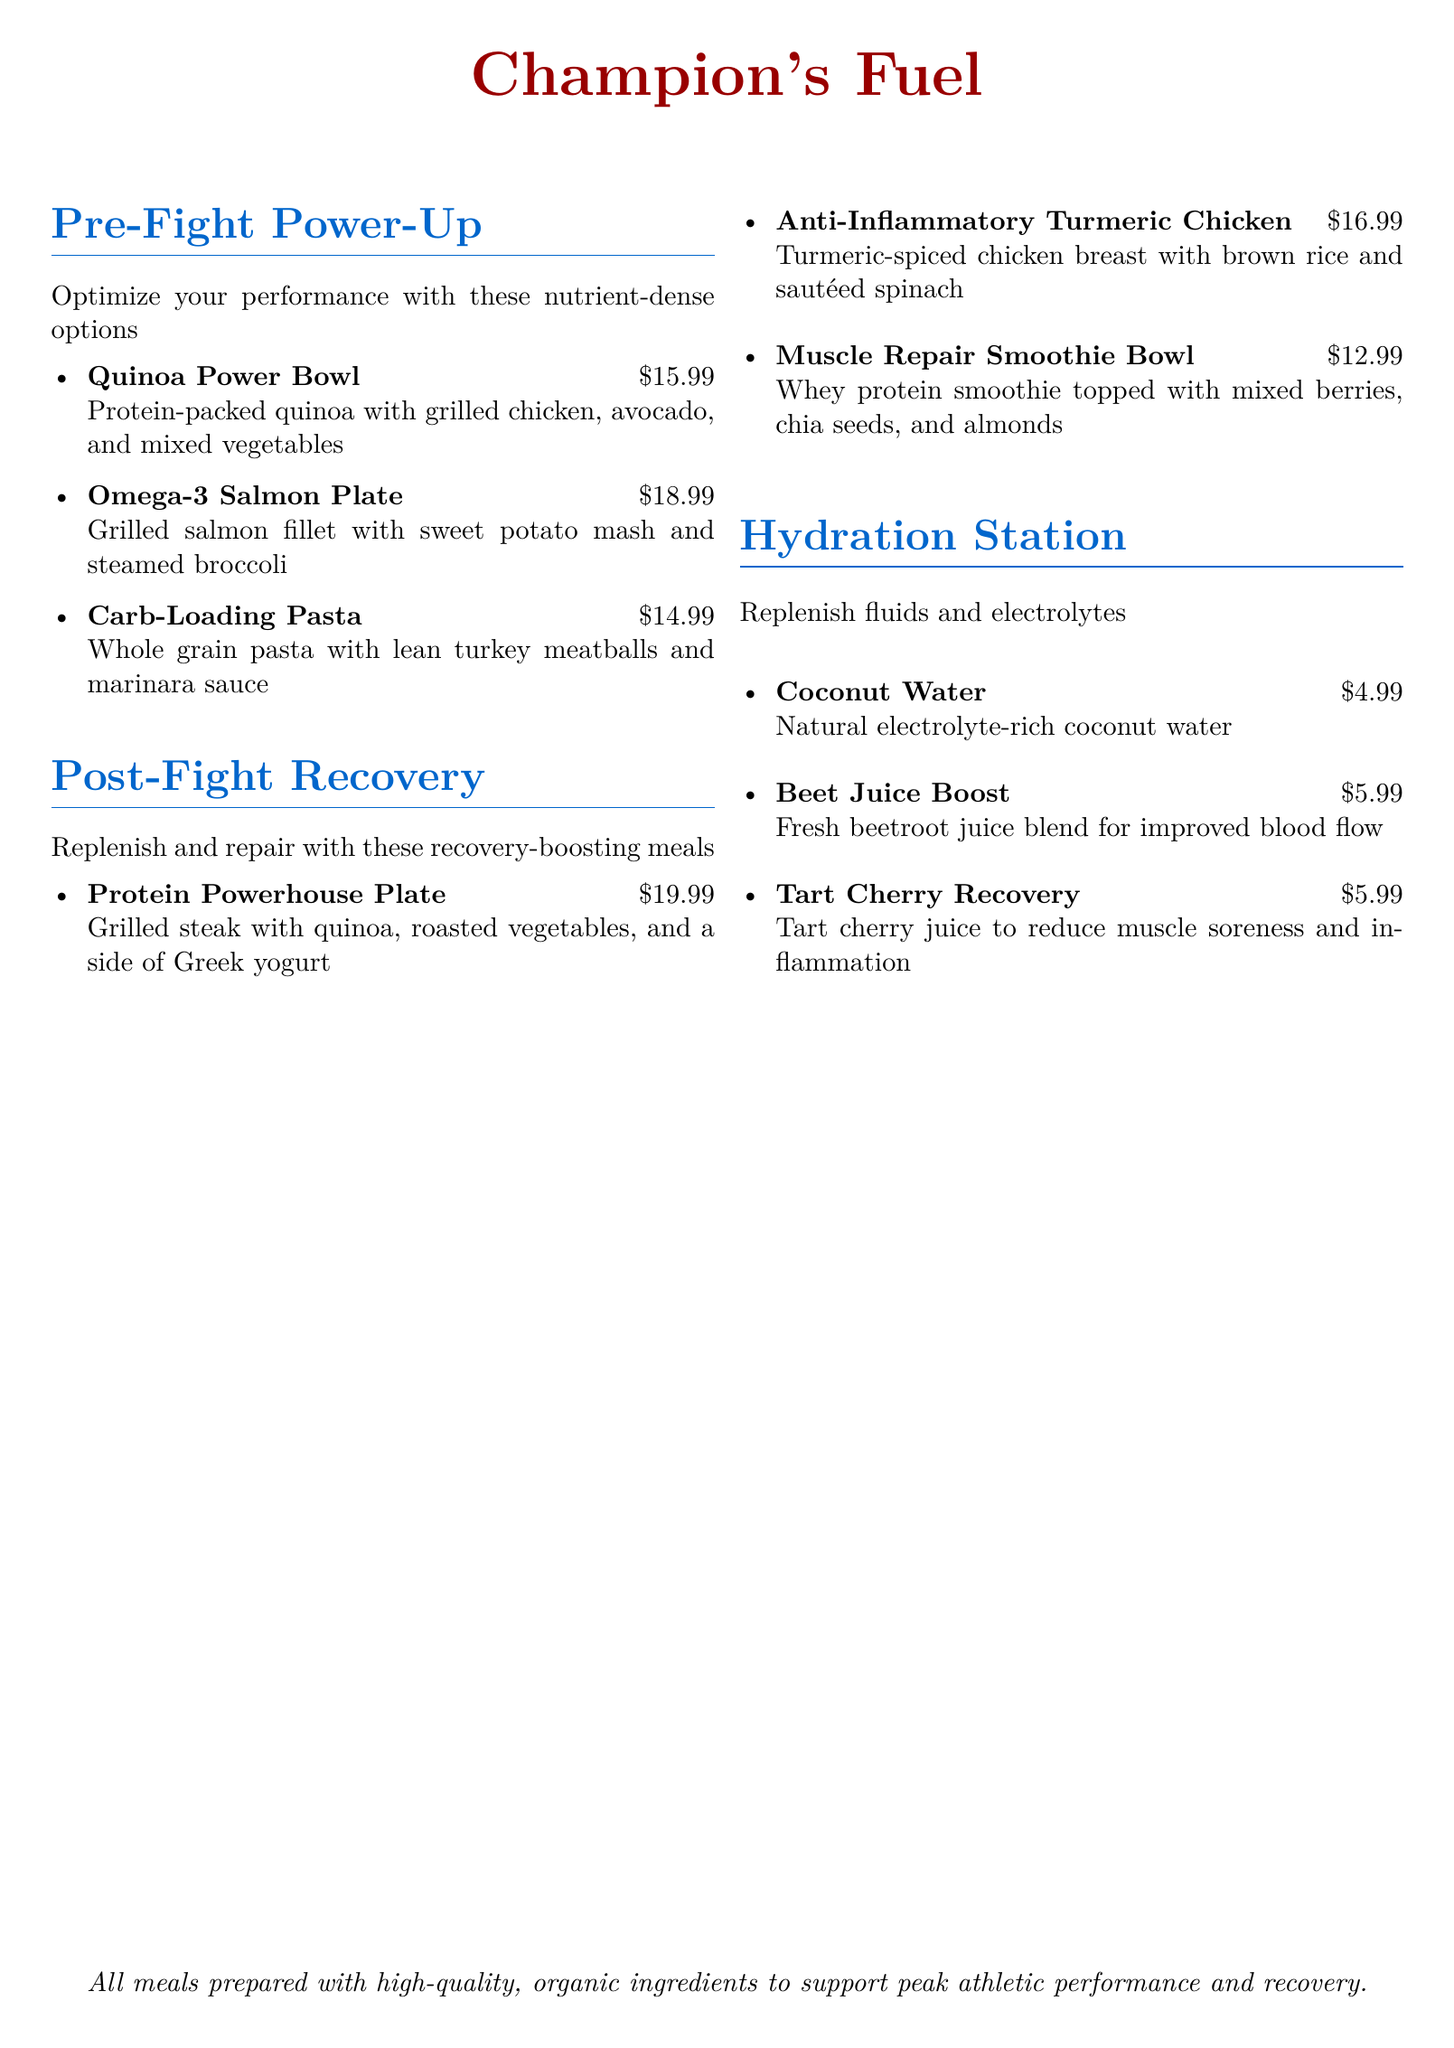What is the name of the restaurant? The name of the restaurant is clearly stated at the top of the document.
Answer: Champion's Fuel What is the price of the Omega-3 Salmon Plate? The price of each dish is listed next to the name. The Omega-3 Salmon Plate is priced at $18.99.
Answer: $18.99 How many items are included in the Pre-Fight menu? The number of items can be determined by counting the bullet points under the Pre-Fight section. There are three items.
Answer: 3 What is a key ingredient in the Muscle Repair Smoothie Bowl? The ingredients of each dish are listed, and a key ingredient for the Muscle Repair Smoothie Bowl is whey protein.
Answer: Whey protein Which dish contains turmeric? The dish that includes turmeric is explicitly mentioned in the Post-Fight Recovery section.
Answer: Anti-Inflammatory Turmeric Chicken What drink is suggested for improved blood flow? The drink recommendations include a specific benefit; the one for improved blood flow is mentioned.
Answer: Beet Juice Boost What type of pasta is used in the Carb-Loading Pasta? The document describes the type of pasta used, which is whole grain pasta.
Answer: Whole grain What is the total number of hydration options listed? By counting the items in the Hydration Station section, you can find the total number of drink options. There are three options.
Answer: 3 What meal is referred to as a Protein Powerhouse? The meal name is explicitly stated in the Post-Fight Recovery section.
Answer: Protein Powerhouse Plate 